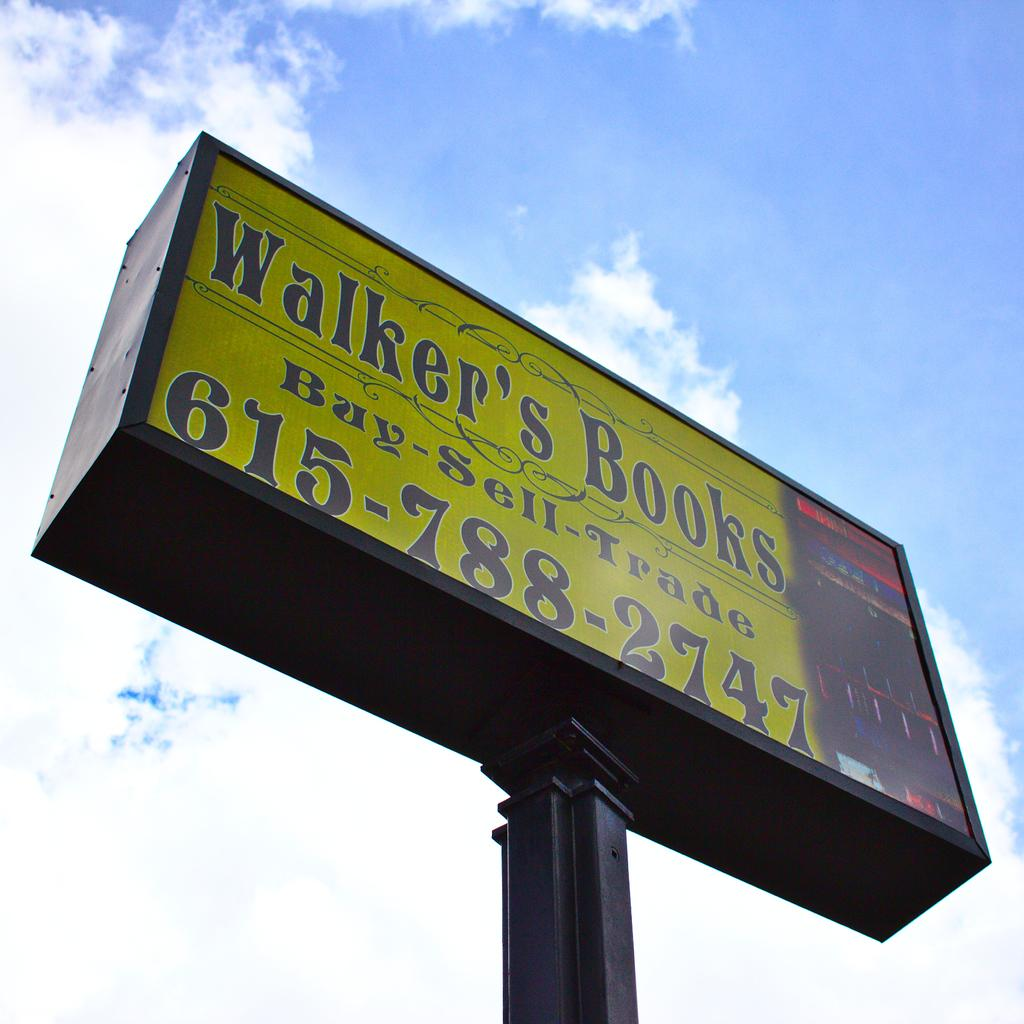<image>
Describe the image concisely. Walker's Books will buy, sell and trade other books. 